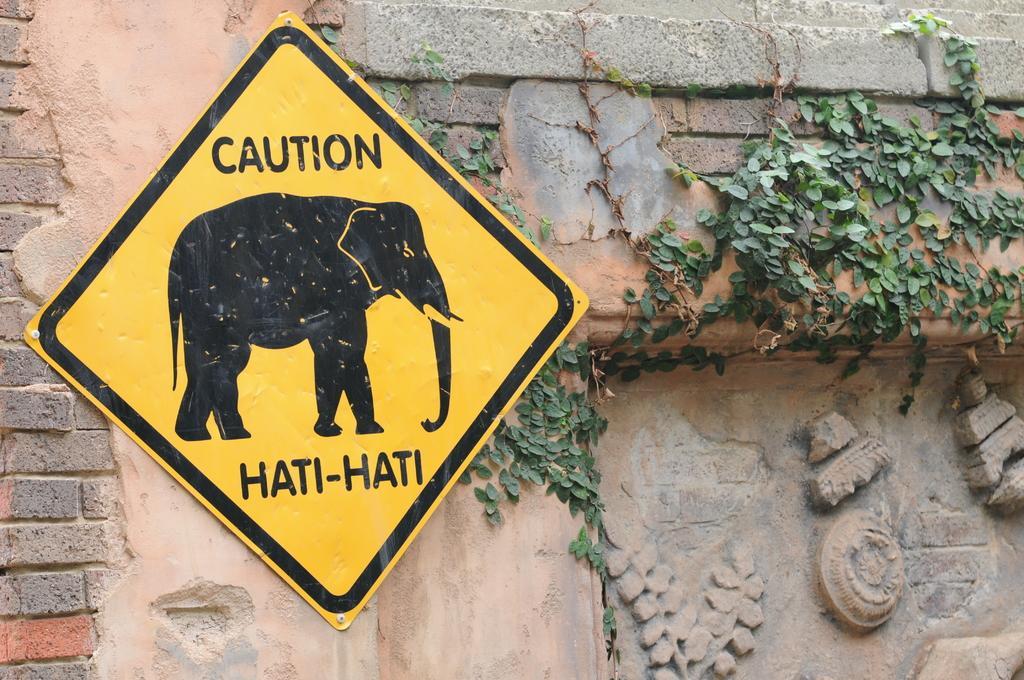How would you summarize this image in a sentence or two? In this image I can see a board which is in yellow color, in the board I can see an elephant and the board is attached to the wall. I can also see a small plant in green color. 